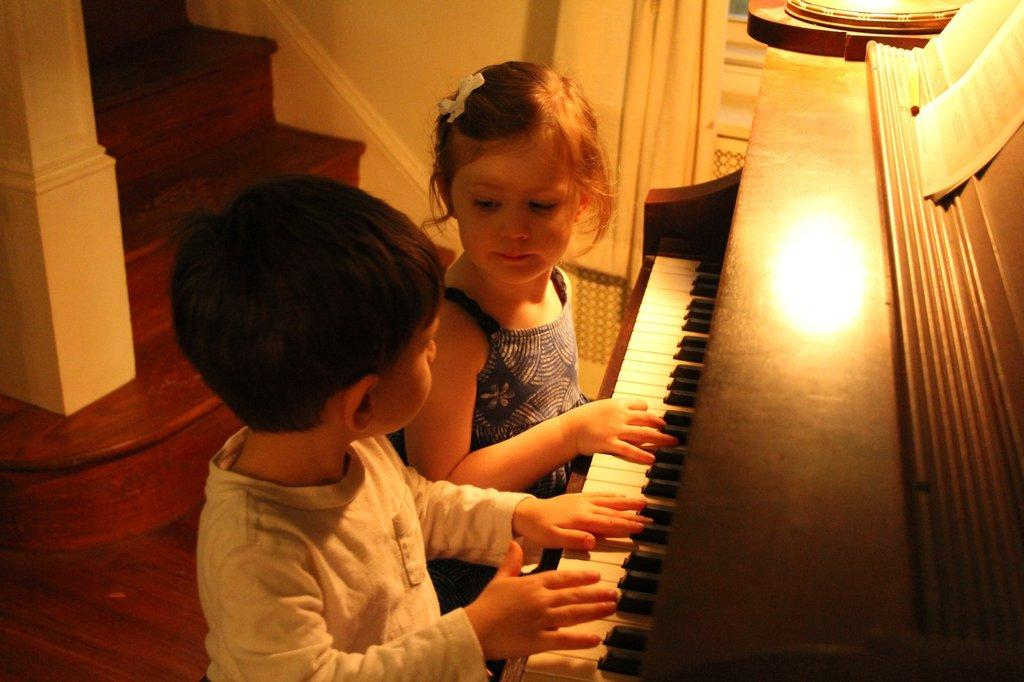How many people are in the image? There are two people in the image, a boy and a girl. What are the boy and girl doing in the image? Both the boy and girl are playing the piano. What can be seen on the piano? There are papers on the piano. What architectural feature is visible in the background? There are steps visible in the background. What type of window treatment is present in the image? There is a curtain associated with a window. What type of government is depicted in the image? There is no depiction of a government in the image; it features a boy and girl playing the piano. Can you tell me how many crows are visible in the image? There are no crows present in the image. 